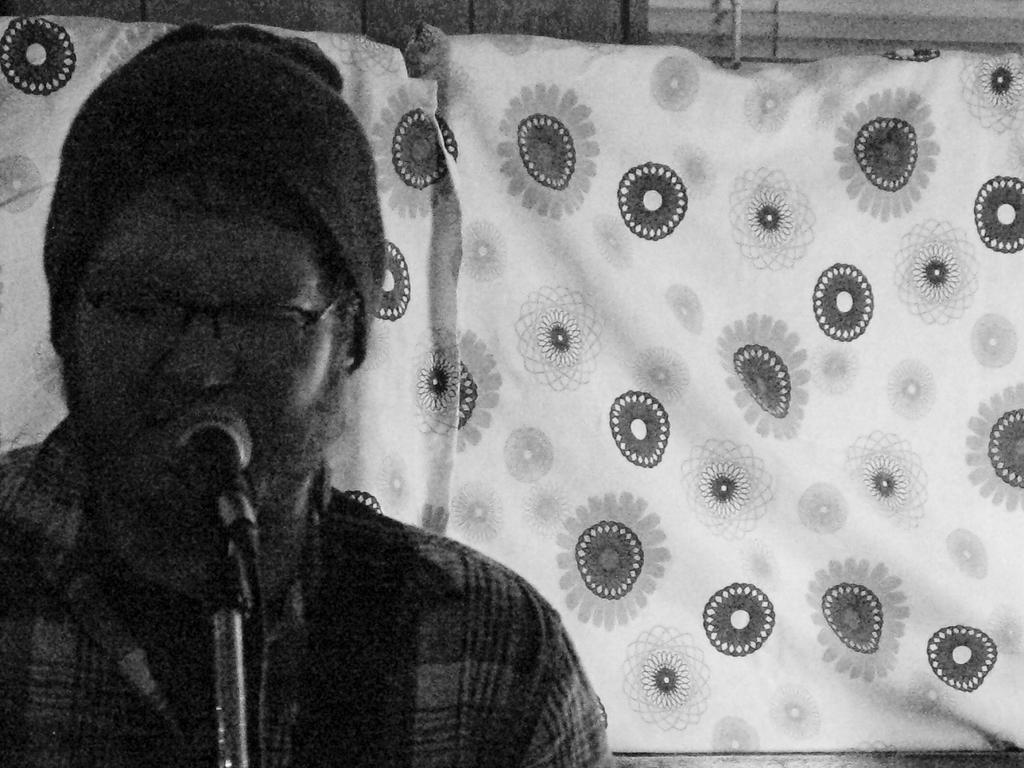What is the man in the image doing? The man is singing on a microphone. What accessories is the man wearing in the image? The man is wearing spectacles, a cap, and a shirt. How many rabbits can be seen in the image? There are no rabbits present in the image. What tool is the man using to start the performance in the image? The man is not using any tool to start the performance; he is singing on a microphone. 